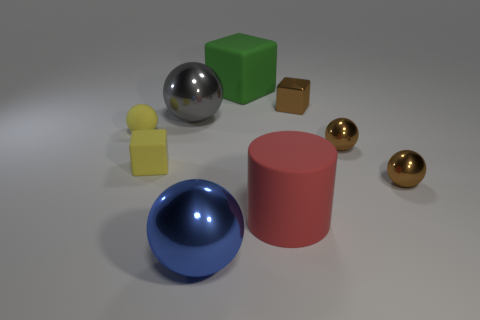Subtract all rubber spheres. How many spheres are left? 4 Subtract all green balls. Subtract all blue cubes. How many balls are left? 5 Add 1 big red rubber things. How many objects exist? 10 Subtract all cubes. How many objects are left? 6 Add 8 big matte blocks. How many big matte blocks exist? 9 Subtract 0 red balls. How many objects are left? 9 Subtract all gray matte spheres. Subtract all large red things. How many objects are left? 8 Add 7 gray shiny spheres. How many gray shiny spheres are left? 8 